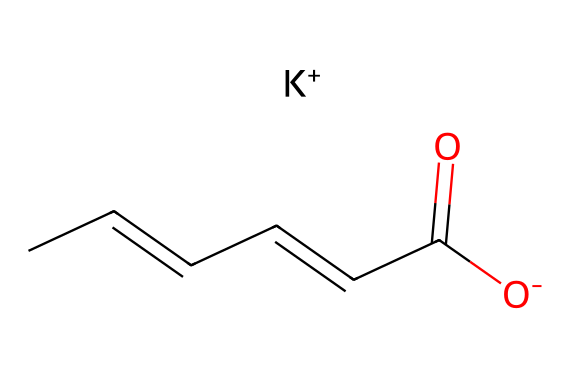What is the molecular formula of potassium sorbate? The SMILES representation indicates the presence of carbon (C), hydrogen (H), oxygen (O), and potassium (K). Counting the atoms from the SMILES yields 6 carbon, 8 hydrogen, 1 oxygen (in the carboxylate form), and 1 potassium. Thus, the molecular formula is derived as C6H7KO2.
Answer: C6H7KO2 How many carbon atoms are present in potassium sorbate? By analyzing the SMILES, we identify six carbon atoms indicated by the 'C' characters in the chain. Each 'C' represents a carbon atom in the structure.
Answer: 6 What is the functional group in potassium sorbate? The presence of the carboxylate (–COO-) within the structure signifies a carboxylic acid functional group that is deprotonated in this case (indicated by [O-]). This group is characteristic of food preservatives.
Answer: carboxylate How many hydrogen atoms are connected to the carbon chain in potassium sorbate? In the SMILES, hydrogens are implicitly connected to carbon atoms; specifically, we count 7 directly connected to the 6 carbons shown, ensuring that each carbon can form four bonds. Thus, the total is 7 hydrogen atoms.
Answer: 7 Is potassium sorbate anionic or cationic at physiological pH? The SMILES shows a negatively charged oxygen ([O-]), indicating that potassium sorbate exists as an anion in solution, as the carboxylate group (-COO-) is what gives the compound its anionic character when in solution.
Answer: anionic What role does potassium play in potassium sorbate? Potassium (K+) serves as the counterion to balance the negative charge from the carboxylate group [O-], thus stabilizing the overall molecular structure. This is critical for its function as a preservative.
Answer: counterion What type of food additive is potassium sorbate classified as? Based on its usage in food preservation, potassium sorbate is classified as a preservative. The structure supports its role in preventing mold and yeast growth in food products.
Answer: preservative 